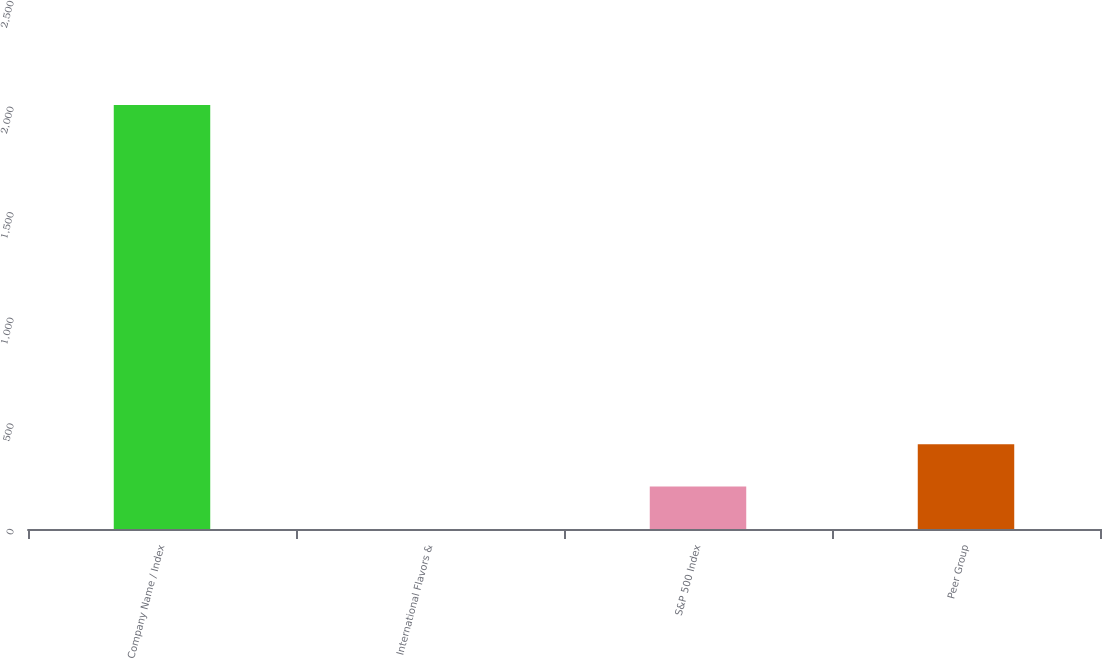<chart> <loc_0><loc_0><loc_500><loc_500><bar_chart><fcel>Company Name / Index<fcel>International Flavors &<fcel>S&P 500 Index<fcel>Peer Group<nl><fcel>2007<fcel>0.36<fcel>201.02<fcel>401.68<nl></chart> 